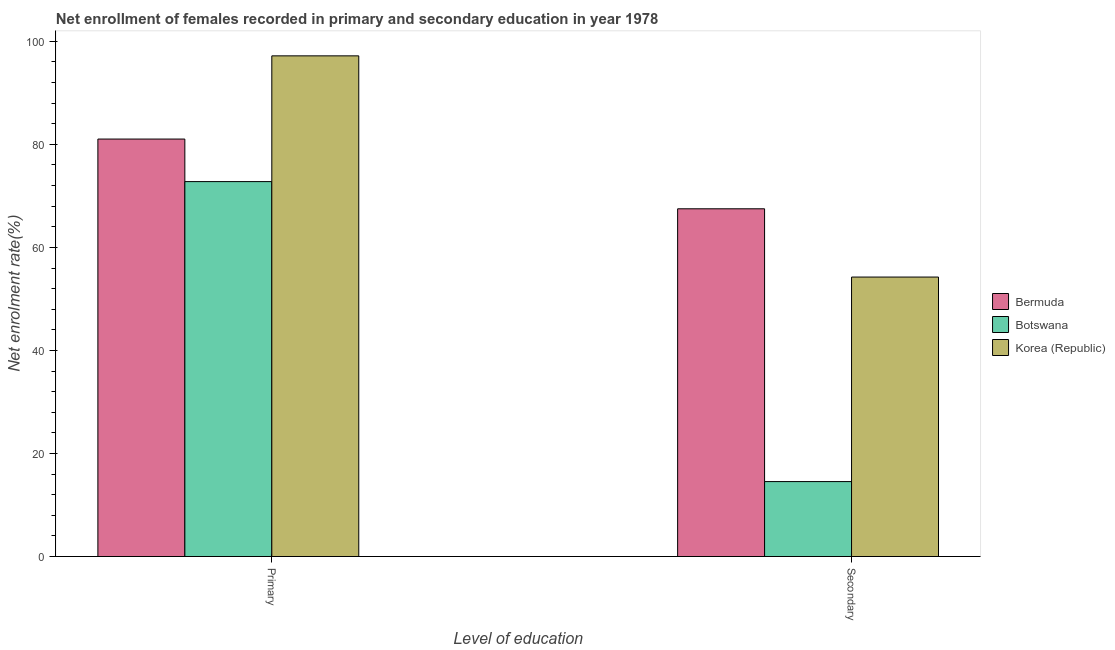How many different coloured bars are there?
Offer a very short reply. 3. Are the number of bars per tick equal to the number of legend labels?
Offer a very short reply. Yes. Are the number of bars on each tick of the X-axis equal?
Your response must be concise. Yes. How many bars are there on the 2nd tick from the right?
Provide a succinct answer. 3. What is the label of the 1st group of bars from the left?
Give a very brief answer. Primary. What is the enrollment rate in secondary education in Korea (Republic)?
Provide a succinct answer. 54.25. Across all countries, what is the maximum enrollment rate in secondary education?
Offer a very short reply. 67.5. Across all countries, what is the minimum enrollment rate in secondary education?
Ensure brevity in your answer.  14.55. In which country was the enrollment rate in secondary education minimum?
Ensure brevity in your answer.  Botswana. What is the total enrollment rate in secondary education in the graph?
Ensure brevity in your answer.  136.29. What is the difference between the enrollment rate in primary education in Botswana and that in Korea (Republic)?
Ensure brevity in your answer.  -24.41. What is the difference between the enrollment rate in primary education in Botswana and the enrollment rate in secondary education in Bermuda?
Make the answer very short. 5.28. What is the average enrollment rate in secondary education per country?
Ensure brevity in your answer.  45.43. What is the difference between the enrollment rate in secondary education and enrollment rate in primary education in Bermuda?
Make the answer very short. -13.54. In how many countries, is the enrollment rate in secondary education greater than 84 %?
Your answer should be very brief. 0. What is the ratio of the enrollment rate in primary education in Korea (Republic) to that in Botswana?
Your response must be concise. 1.34. What does the 3rd bar from the left in Primary represents?
Keep it short and to the point. Korea (Republic). What does the 3rd bar from the right in Primary represents?
Keep it short and to the point. Bermuda. How many countries are there in the graph?
Ensure brevity in your answer.  3. Are the values on the major ticks of Y-axis written in scientific E-notation?
Your answer should be very brief. No. Does the graph contain grids?
Keep it short and to the point. No. Where does the legend appear in the graph?
Your answer should be compact. Center right. How many legend labels are there?
Provide a succinct answer. 3. What is the title of the graph?
Offer a very short reply. Net enrollment of females recorded in primary and secondary education in year 1978. What is the label or title of the X-axis?
Offer a terse response. Level of education. What is the label or title of the Y-axis?
Keep it short and to the point. Net enrolment rate(%). What is the Net enrolment rate(%) of Bermuda in Primary?
Your response must be concise. 81.03. What is the Net enrolment rate(%) of Botswana in Primary?
Keep it short and to the point. 72.77. What is the Net enrolment rate(%) in Korea (Republic) in Primary?
Give a very brief answer. 97.18. What is the Net enrolment rate(%) in Bermuda in Secondary?
Ensure brevity in your answer.  67.5. What is the Net enrolment rate(%) of Botswana in Secondary?
Your response must be concise. 14.55. What is the Net enrolment rate(%) in Korea (Republic) in Secondary?
Your response must be concise. 54.25. Across all Level of education, what is the maximum Net enrolment rate(%) in Bermuda?
Provide a short and direct response. 81.03. Across all Level of education, what is the maximum Net enrolment rate(%) in Botswana?
Make the answer very short. 72.77. Across all Level of education, what is the maximum Net enrolment rate(%) of Korea (Republic)?
Ensure brevity in your answer.  97.18. Across all Level of education, what is the minimum Net enrolment rate(%) in Bermuda?
Your response must be concise. 67.5. Across all Level of education, what is the minimum Net enrolment rate(%) of Botswana?
Your response must be concise. 14.55. Across all Level of education, what is the minimum Net enrolment rate(%) in Korea (Republic)?
Your response must be concise. 54.25. What is the total Net enrolment rate(%) in Bermuda in the graph?
Make the answer very short. 148.53. What is the total Net enrolment rate(%) in Botswana in the graph?
Provide a succinct answer. 87.32. What is the total Net enrolment rate(%) of Korea (Republic) in the graph?
Offer a very short reply. 151.43. What is the difference between the Net enrolment rate(%) in Bermuda in Primary and that in Secondary?
Offer a terse response. 13.54. What is the difference between the Net enrolment rate(%) of Botswana in Primary and that in Secondary?
Your answer should be very brief. 58.23. What is the difference between the Net enrolment rate(%) in Korea (Republic) in Primary and that in Secondary?
Your response must be concise. 42.94. What is the difference between the Net enrolment rate(%) in Bermuda in Primary and the Net enrolment rate(%) in Botswana in Secondary?
Keep it short and to the point. 66.49. What is the difference between the Net enrolment rate(%) of Bermuda in Primary and the Net enrolment rate(%) of Korea (Republic) in Secondary?
Ensure brevity in your answer.  26.79. What is the difference between the Net enrolment rate(%) in Botswana in Primary and the Net enrolment rate(%) in Korea (Republic) in Secondary?
Offer a very short reply. 18.53. What is the average Net enrolment rate(%) in Bermuda per Level of education?
Keep it short and to the point. 74.26. What is the average Net enrolment rate(%) of Botswana per Level of education?
Your response must be concise. 43.66. What is the average Net enrolment rate(%) of Korea (Republic) per Level of education?
Your answer should be very brief. 75.71. What is the difference between the Net enrolment rate(%) of Bermuda and Net enrolment rate(%) of Botswana in Primary?
Keep it short and to the point. 8.26. What is the difference between the Net enrolment rate(%) of Bermuda and Net enrolment rate(%) of Korea (Republic) in Primary?
Offer a very short reply. -16.15. What is the difference between the Net enrolment rate(%) in Botswana and Net enrolment rate(%) in Korea (Republic) in Primary?
Offer a terse response. -24.41. What is the difference between the Net enrolment rate(%) in Bermuda and Net enrolment rate(%) in Botswana in Secondary?
Your answer should be very brief. 52.95. What is the difference between the Net enrolment rate(%) in Bermuda and Net enrolment rate(%) in Korea (Republic) in Secondary?
Make the answer very short. 13.25. What is the difference between the Net enrolment rate(%) of Botswana and Net enrolment rate(%) of Korea (Republic) in Secondary?
Your answer should be compact. -39.7. What is the ratio of the Net enrolment rate(%) of Bermuda in Primary to that in Secondary?
Keep it short and to the point. 1.2. What is the ratio of the Net enrolment rate(%) in Botswana in Primary to that in Secondary?
Provide a short and direct response. 5. What is the ratio of the Net enrolment rate(%) of Korea (Republic) in Primary to that in Secondary?
Keep it short and to the point. 1.79. What is the difference between the highest and the second highest Net enrolment rate(%) in Bermuda?
Your answer should be very brief. 13.54. What is the difference between the highest and the second highest Net enrolment rate(%) of Botswana?
Provide a succinct answer. 58.23. What is the difference between the highest and the second highest Net enrolment rate(%) in Korea (Republic)?
Offer a very short reply. 42.94. What is the difference between the highest and the lowest Net enrolment rate(%) in Bermuda?
Provide a short and direct response. 13.54. What is the difference between the highest and the lowest Net enrolment rate(%) of Botswana?
Your answer should be compact. 58.23. What is the difference between the highest and the lowest Net enrolment rate(%) in Korea (Republic)?
Offer a terse response. 42.94. 